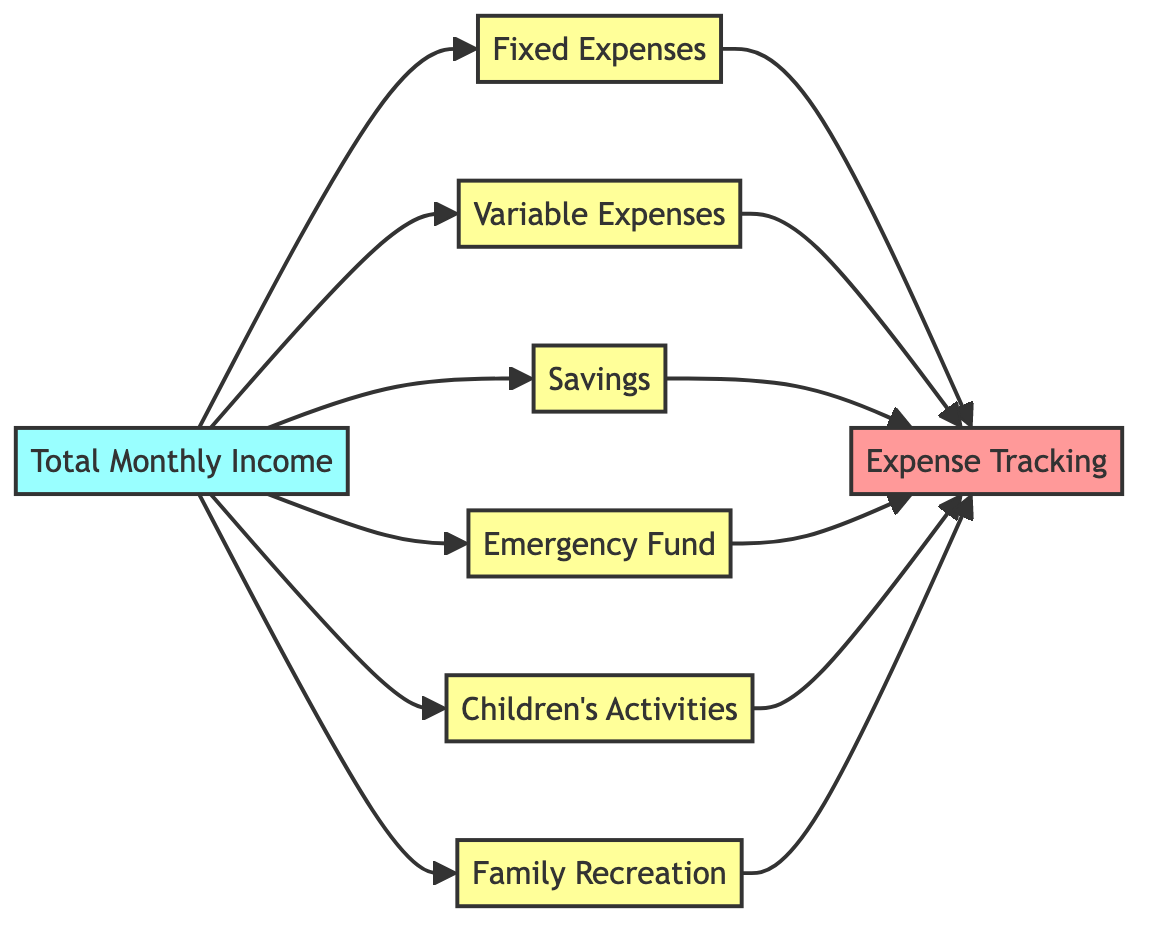What is the total number of elements in the diagram? The diagram includes a total of 8 elements, including the main node for total monthly income and the various expense categories that branch out from it.
Answer: 8 What type of expenses has a direct connection to Total Monthly Income? The direct connections to Total Monthly Income include Fixed Expenses, Variable Expenses, Savings, Emergency Fund, Children's Activities, and Family Recreation. These categories represent the main allocations from the income.
Answer: Fixed, Variable, Savings, Emergency Fund, Children's Activities, Family Recreation Which node tracks all expenses? The Expense Tracking node at the end of the flowchart is responsible for monitoring all categorized expenses to ensure that the budget is followed correctly.
Answer: Expense Tracking What are the types of expenses listed in the diagram? The diagram lists Fixed Expenses, Variable Expenses, Savings, Emergency Fund, Children's Activities, and Family Recreation as the different types of expenses that can be allocated from the total monthly income.
Answer: Fixed, Variable, Savings, Emergency Fund, Children's Activities, Family Recreation How many distinct connections are there from the Total Monthly Income to other nodes? There are 6 distinct connections from the Total Monthly Income node to the expense categories: Fixed Expenses, Variable Expenses, Savings, Emergency Fund, Children's Activities, and Family Recreation. Adding these connections gives us the total.
Answer: 6 Which type of expenses is typically variable? Variable Expenses are costs that can fluctuate from month to month, such as groceries, dining out, or entertainment activities, distinguishing them from fixed expenses which remain constant.
Answer: Variable Expenses Which nodes are considered as expenses? The nodes that are categorized as expenses include Fixed Expenses, Variable Expenses, Savings, Emergency Fund, Children's Activities, and Family Recreation, all branching from the Total Monthly Income.
Answer: Fixed, Variable, Savings, Emergency Fund, Children's Activities, Family Recreation What is the relationship between expenses and tracking in this diagram? In the diagram, all types of expenses (Fixed, Variable, Savings, Emergency Fund, Children's Activities, and Family Recreation) have a direct flow to the Expense Tracking node, indicating that all expenses need to be recorded and monitored.
Answer: All expenses connect to Expense Tracking 